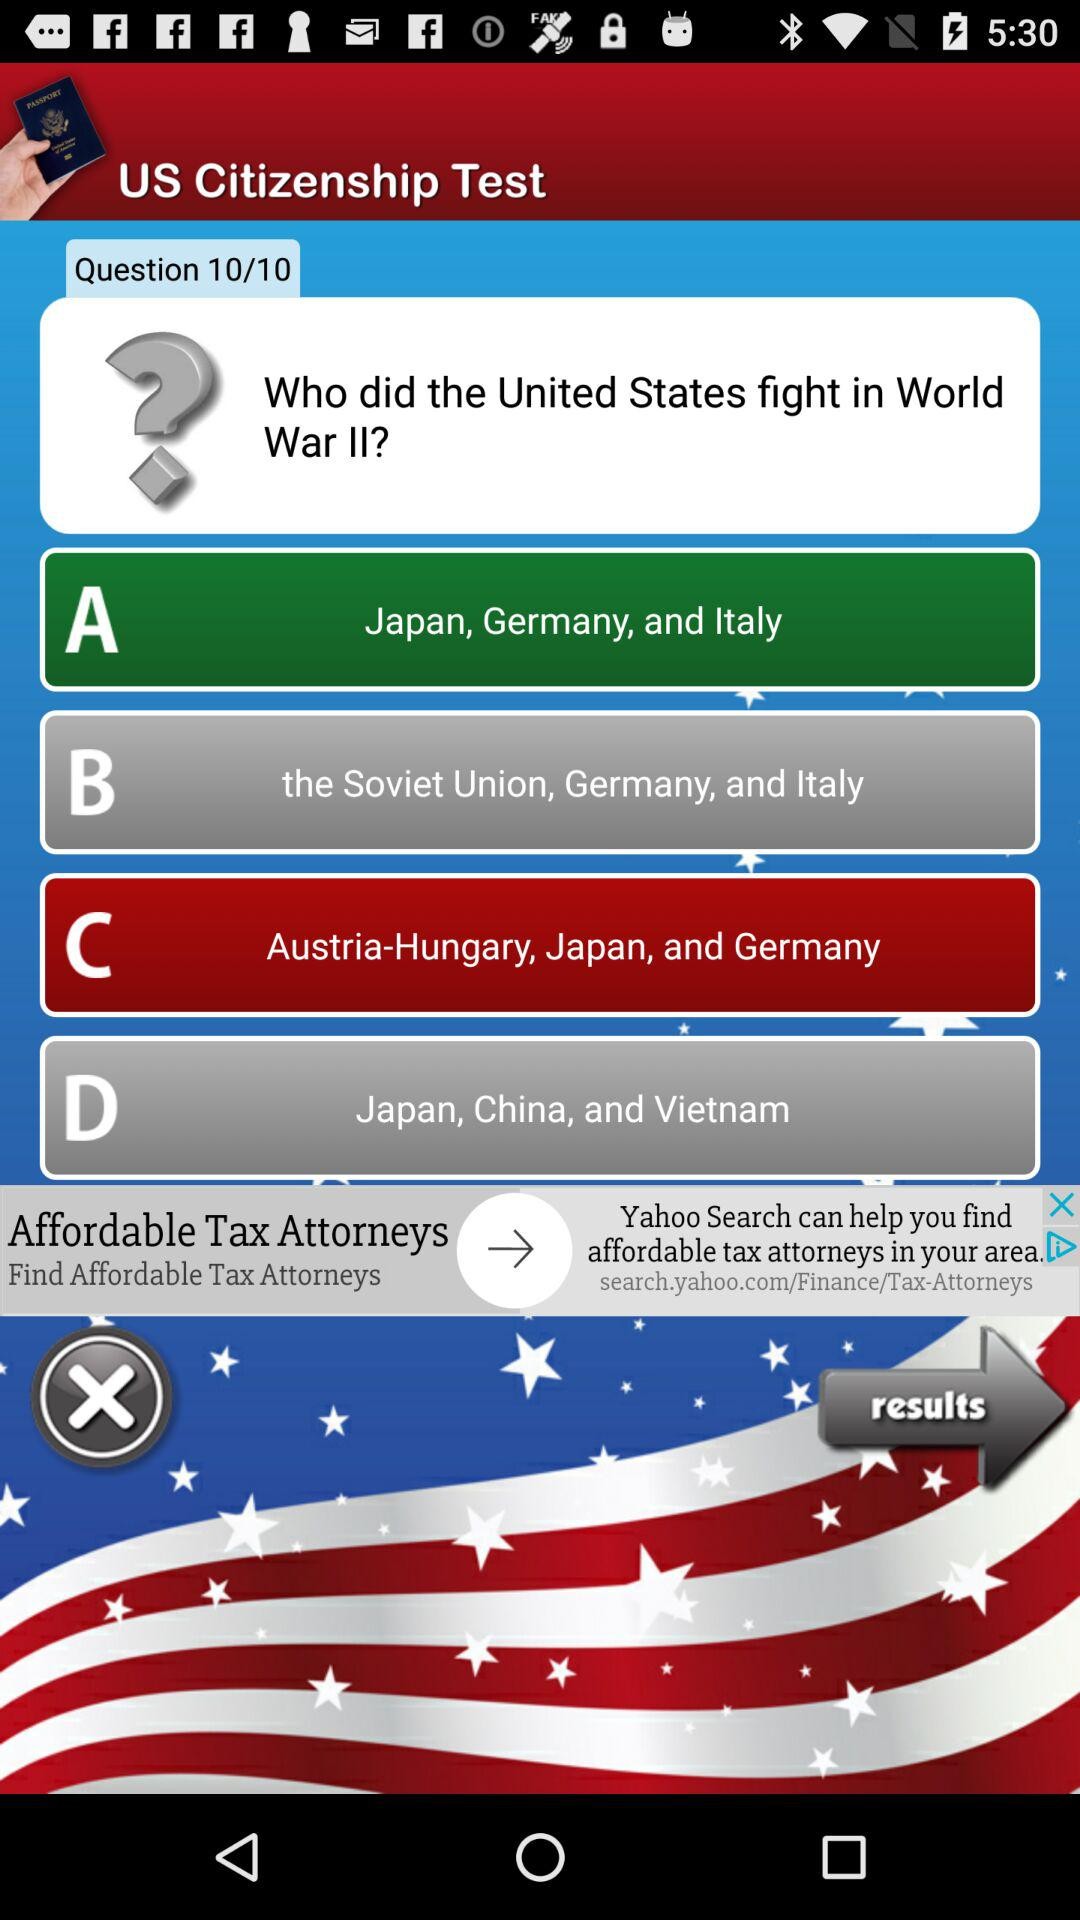How many options are there to choose from?
Answer the question using a single word or phrase. 4 